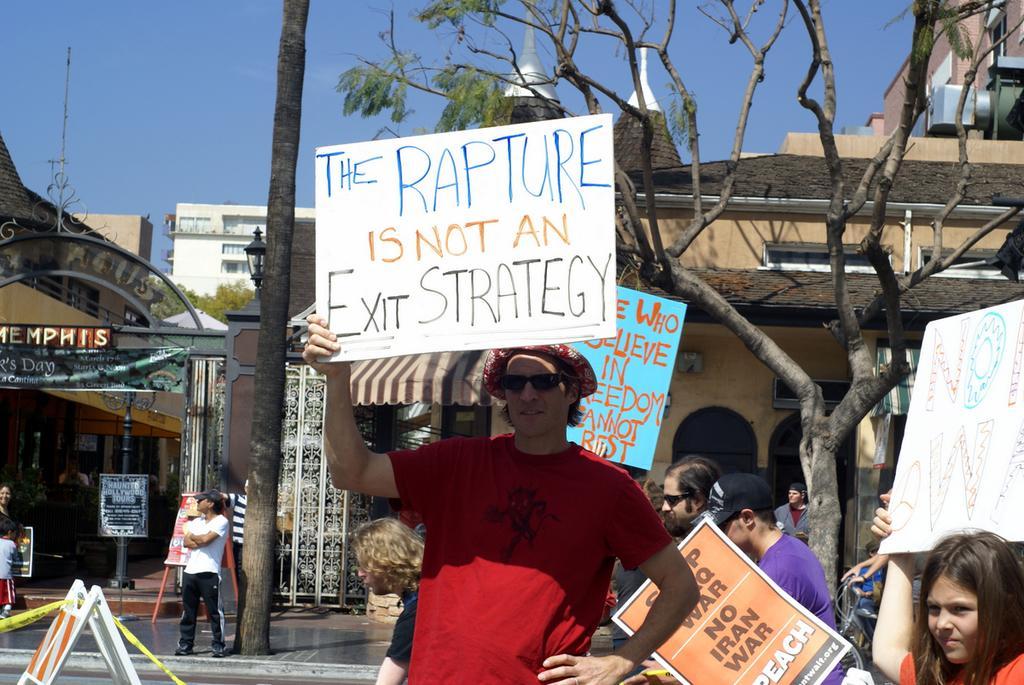How would you summarize this image in a sentence or two? In the image there is a building and in front of the building there are a group of people on the right side, they are holding some posters with their hands and protesting against something. Behind them there are trees. 